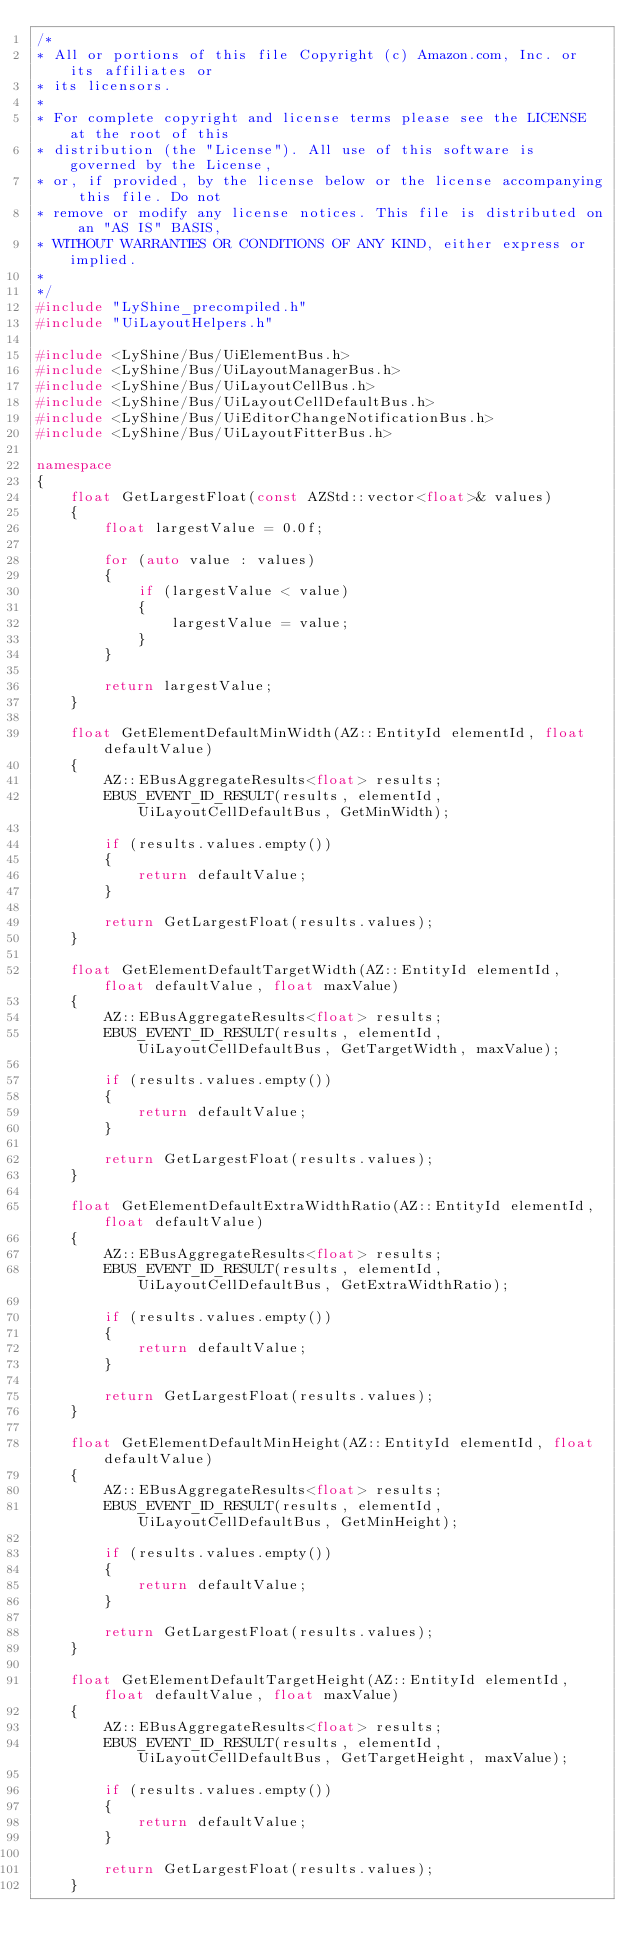Convert code to text. <code><loc_0><loc_0><loc_500><loc_500><_C++_>/*
* All or portions of this file Copyright (c) Amazon.com, Inc. or its affiliates or
* its licensors.
*
* For complete copyright and license terms please see the LICENSE at the root of this
* distribution (the "License"). All use of this software is governed by the License,
* or, if provided, by the license below or the license accompanying this file. Do not
* remove or modify any license notices. This file is distributed on an "AS IS" BASIS,
* WITHOUT WARRANTIES OR CONDITIONS OF ANY KIND, either express or implied.
*
*/
#include "LyShine_precompiled.h"
#include "UiLayoutHelpers.h"

#include <LyShine/Bus/UiElementBus.h>
#include <LyShine/Bus/UiLayoutManagerBus.h>
#include <LyShine/Bus/UiLayoutCellBus.h>
#include <LyShine/Bus/UiLayoutCellDefaultBus.h>
#include <LyShine/Bus/UiEditorChangeNotificationBus.h>
#include <LyShine/Bus/UiLayoutFitterBus.h>

namespace
{
    float GetLargestFloat(const AZStd::vector<float>& values)
    {
        float largestValue = 0.0f;

        for (auto value : values)
        {
            if (largestValue < value)
            {
                largestValue = value;
            }
        }

        return largestValue;
    }

    float GetElementDefaultMinWidth(AZ::EntityId elementId, float defaultValue)
    {
        AZ::EBusAggregateResults<float> results;
        EBUS_EVENT_ID_RESULT(results, elementId, UiLayoutCellDefaultBus, GetMinWidth);

        if (results.values.empty())
        {
            return defaultValue;
        }

        return GetLargestFloat(results.values);
    }

    float GetElementDefaultTargetWidth(AZ::EntityId elementId, float defaultValue, float maxValue)
    {
        AZ::EBusAggregateResults<float> results;
        EBUS_EVENT_ID_RESULT(results, elementId, UiLayoutCellDefaultBus, GetTargetWidth, maxValue);

        if (results.values.empty())
        {
            return defaultValue;
        }

        return GetLargestFloat(results.values);
    }

    float GetElementDefaultExtraWidthRatio(AZ::EntityId elementId, float defaultValue)
    {
        AZ::EBusAggregateResults<float> results;
        EBUS_EVENT_ID_RESULT(results, elementId, UiLayoutCellDefaultBus, GetExtraWidthRatio);

        if (results.values.empty())
        {
            return defaultValue;
        }

        return GetLargestFloat(results.values);
    }

    float GetElementDefaultMinHeight(AZ::EntityId elementId, float defaultValue)
    {
        AZ::EBusAggregateResults<float> results;
        EBUS_EVENT_ID_RESULT(results, elementId, UiLayoutCellDefaultBus, GetMinHeight);

        if (results.values.empty())
        {
            return defaultValue;
        }

        return GetLargestFloat(results.values);
    }

    float GetElementDefaultTargetHeight(AZ::EntityId elementId, float defaultValue, float maxValue)
    {
        AZ::EBusAggregateResults<float> results;
        EBUS_EVENT_ID_RESULT(results, elementId, UiLayoutCellDefaultBus, GetTargetHeight, maxValue);

        if (results.values.empty())
        {
            return defaultValue;
        }

        return GetLargestFloat(results.values);
    }
</code> 